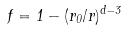<formula> <loc_0><loc_0><loc_500><loc_500>f = 1 - ( r _ { 0 } / r ) ^ { d - 3 }</formula> 